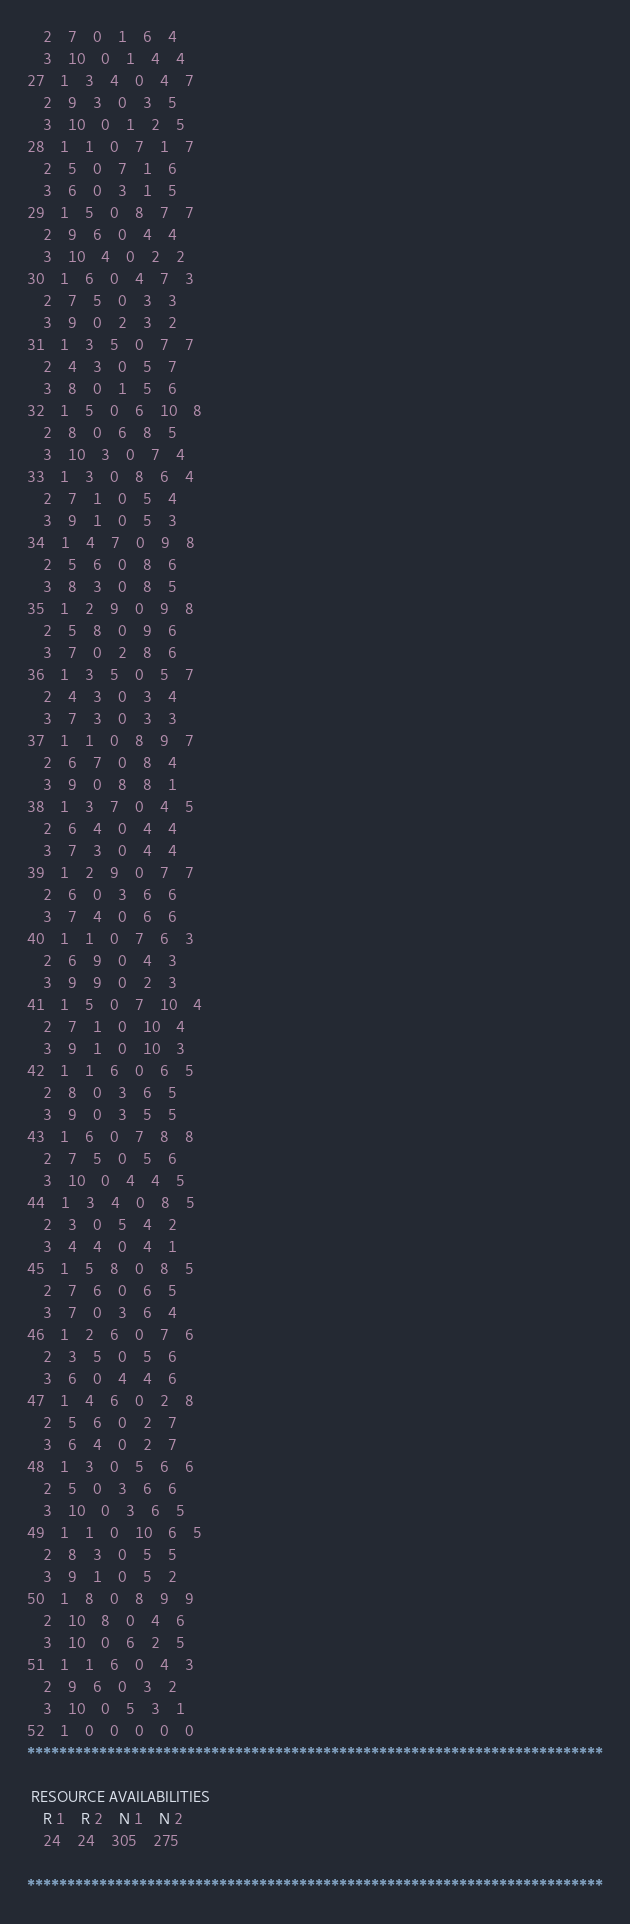<code> <loc_0><loc_0><loc_500><loc_500><_ObjectiveC_>	2	7	0	1	6	4	
	3	10	0	1	4	4	
27	1	3	4	0	4	7	
	2	9	3	0	3	5	
	3	10	0	1	2	5	
28	1	1	0	7	1	7	
	2	5	0	7	1	6	
	3	6	0	3	1	5	
29	1	5	0	8	7	7	
	2	9	6	0	4	4	
	3	10	4	0	2	2	
30	1	6	0	4	7	3	
	2	7	5	0	3	3	
	3	9	0	2	3	2	
31	1	3	5	0	7	7	
	2	4	3	0	5	7	
	3	8	0	1	5	6	
32	1	5	0	6	10	8	
	2	8	0	6	8	5	
	3	10	3	0	7	4	
33	1	3	0	8	6	4	
	2	7	1	0	5	4	
	3	9	1	0	5	3	
34	1	4	7	0	9	8	
	2	5	6	0	8	6	
	3	8	3	0	8	5	
35	1	2	9	0	9	8	
	2	5	8	0	9	6	
	3	7	0	2	8	6	
36	1	3	5	0	5	7	
	2	4	3	0	3	4	
	3	7	3	0	3	3	
37	1	1	0	8	9	7	
	2	6	7	0	8	4	
	3	9	0	8	8	1	
38	1	3	7	0	4	5	
	2	6	4	0	4	4	
	3	7	3	0	4	4	
39	1	2	9	0	7	7	
	2	6	0	3	6	6	
	3	7	4	0	6	6	
40	1	1	0	7	6	3	
	2	6	9	0	4	3	
	3	9	9	0	2	3	
41	1	5	0	7	10	4	
	2	7	1	0	10	4	
	3	9	1	0	10	3	
42	1	1	6	0	6	5	
	2	8	0	3	6	5	
	3	9	0	3	5	5	
43	1	6	0	7	8	8	
	2	7	5	0	5	6	
	3	10	0	4	4	5	
44	1	3	4	0	8	5	
	2	3	0	5	4	2	
	3	4	4	0	4	1	
45	1	5	8	0	8	5	
	2	7	6	0	6	5	
	3	7	0	3	6	4	
46	1	2	6	0	7	6	
	2	3	5	0	5	6	
	3	6	0	4	4	6	
47	1	4	6	0	2	8	
	2	5	6	0	2	7	
	3	6	4	0	2	7	
48	1	3	0	5	6	6	
	2	5	0	3	6	6	
	3	10	0	3	6	5	
49	1	1	0	10	6	5	
	2	8	3	0	5	5	
	3	9	1	0	5	2	
50	1	8	0	8	9	9	
	2	10	8	0	4	6	
	3	10	0	6	2	5	
51	1	1	6	0	4	3	
	2	9	6	0	3	2	
	3	10	0	5	3	1	
52	1	0	0	0	0	0	
************************************************************************

 RESOURCE AVAILABILITIES 
	R 1	R 2	N 1	N 2
	24	24	305	275

************************************************************************
</code> 